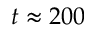<formula> <loc_0><loc_0><loc_500><loc_500>t \approx 2 0 0</formula> 